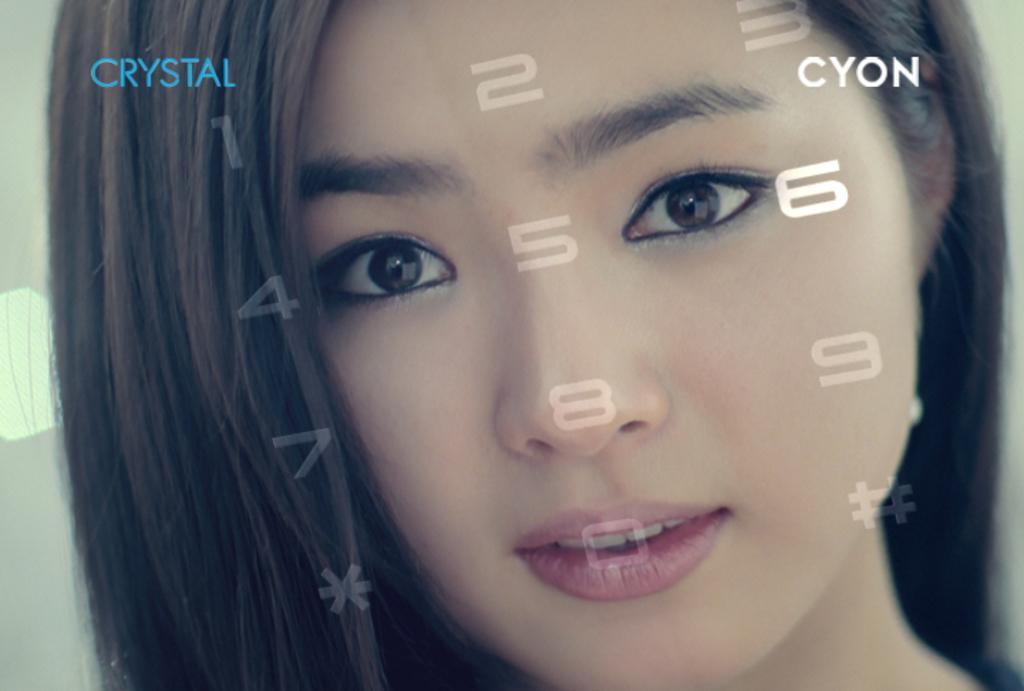Describe this image in one or two sentences. In this picture I can see a woman, and there are watermarks on the image. 